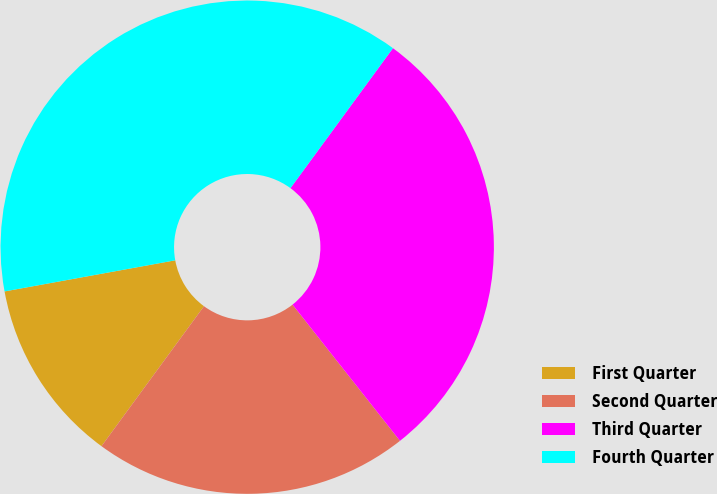Convert chart. <chart><loc_0><loc_0><loc_500><loc_500><pie_chart><fcel>First Quarter<fcel>Second Quarter<fcel>Third Quarter<fcel>Fourth Quarter<nl><fcel>12.07%<fcel>20.69%<fcel>29.31%<fcel>37.93%<nl></chart> 